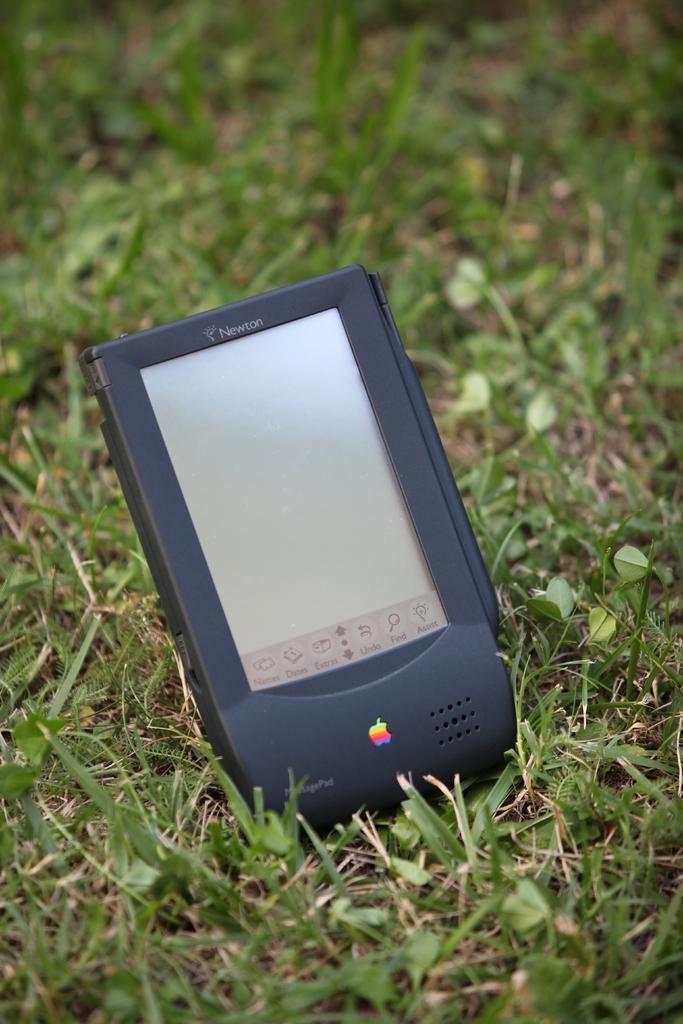In one or two sentences, can you explain what this image depicts? In this image I can see grass and a black colour electronic gadget. 